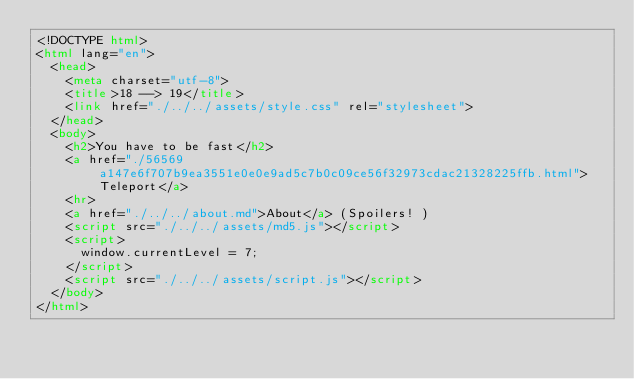Convert code to text. <code><loc_0><loc_0><loc_500><loc_500><_HTML_><!DOCTYPE html>
<html lang="en">
  <head>
    <meta charset="utf-8">
    <title>18 --> 19</title>
    <link href="./../../assets/style.css" rel="stylesheet">
  </head>
  <body>
    <h2>You have to be fast</h2>
    <a href="./56569a147e6f707b9ea3551e0e0e9ad5c7b0c09ce56f32973cdac21328225ffb.html">Teleport</a>
    <hr>
    <a href="./../../about.md">About</a> (Spoilers! )
    <script src="./../../assets/md5.js"></script>
    <script>
      window.currentLevel = 7;
    </script>
    <script src="./../../assets/script.js"></script>
  </body>
</html></code> 